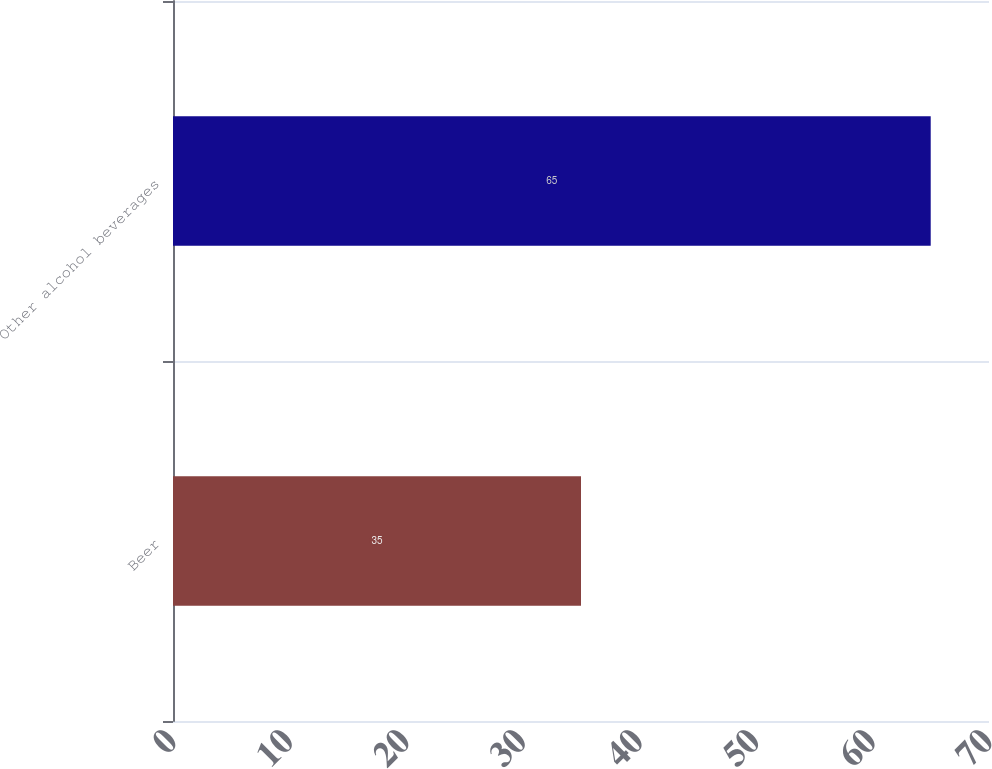Convert chart to OTSL. <chart><loc_0><loc_0><loc_500><loc_500><bar_chart><fcel>Beer<fcel>Other alcohol beverages<nl><fcel>35<fcel>65<nl></chart> 